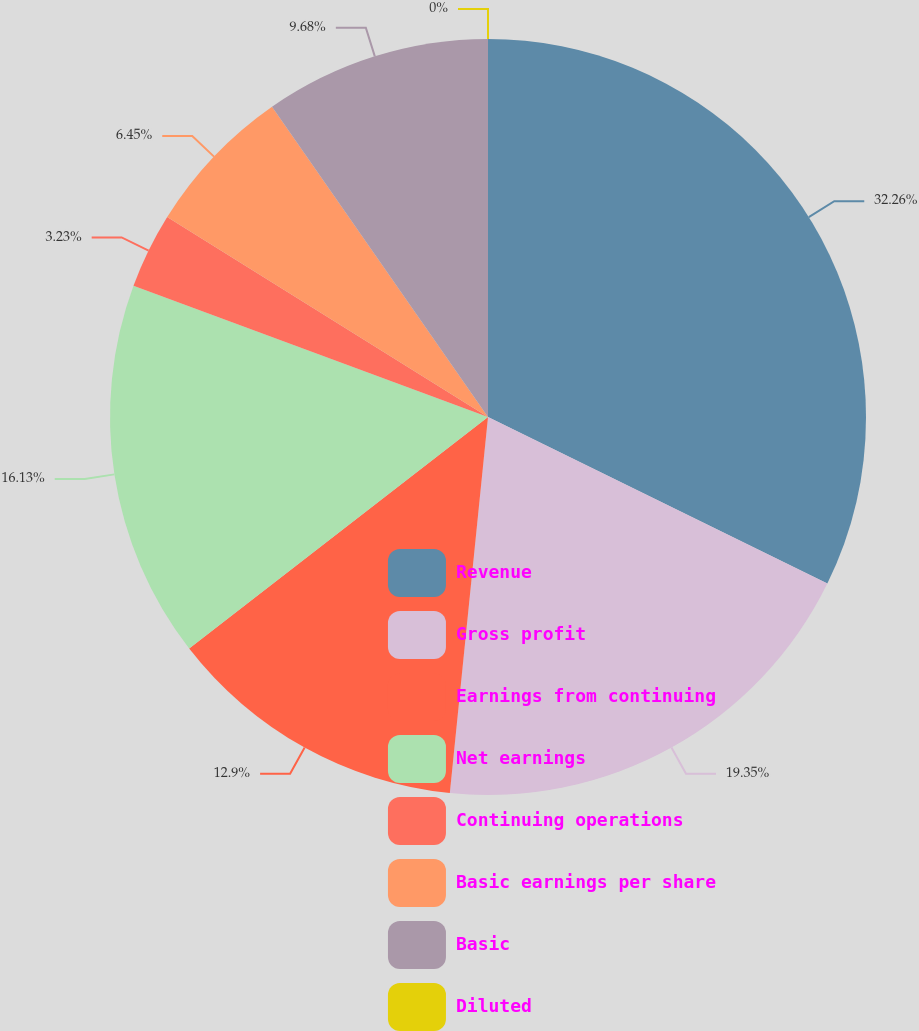Convert chart to OTSL. <chart><loc_0><loc_0><loc_500><loc_500><pie_chart><fcel>Revenue<fcel>Gross profit<fcel>Earnings from continuing<fcel>Net earnings<fcel>Continuing operations<fcel>Basic earnings per share<fcel>Basic<fcel>Diluted<nl><fcel>32.26%<fcel>19.35%<fcel>12.9%<fcel>16.13%<fcel>3.23%<fcel>6.45%<fcel>9.68%<fcel>0.0%<nl></chart> 